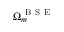<formula> <loc_0><loc_0><loc_500><loc_500>\Omega _ { m } ^ { B S E }</formula> 